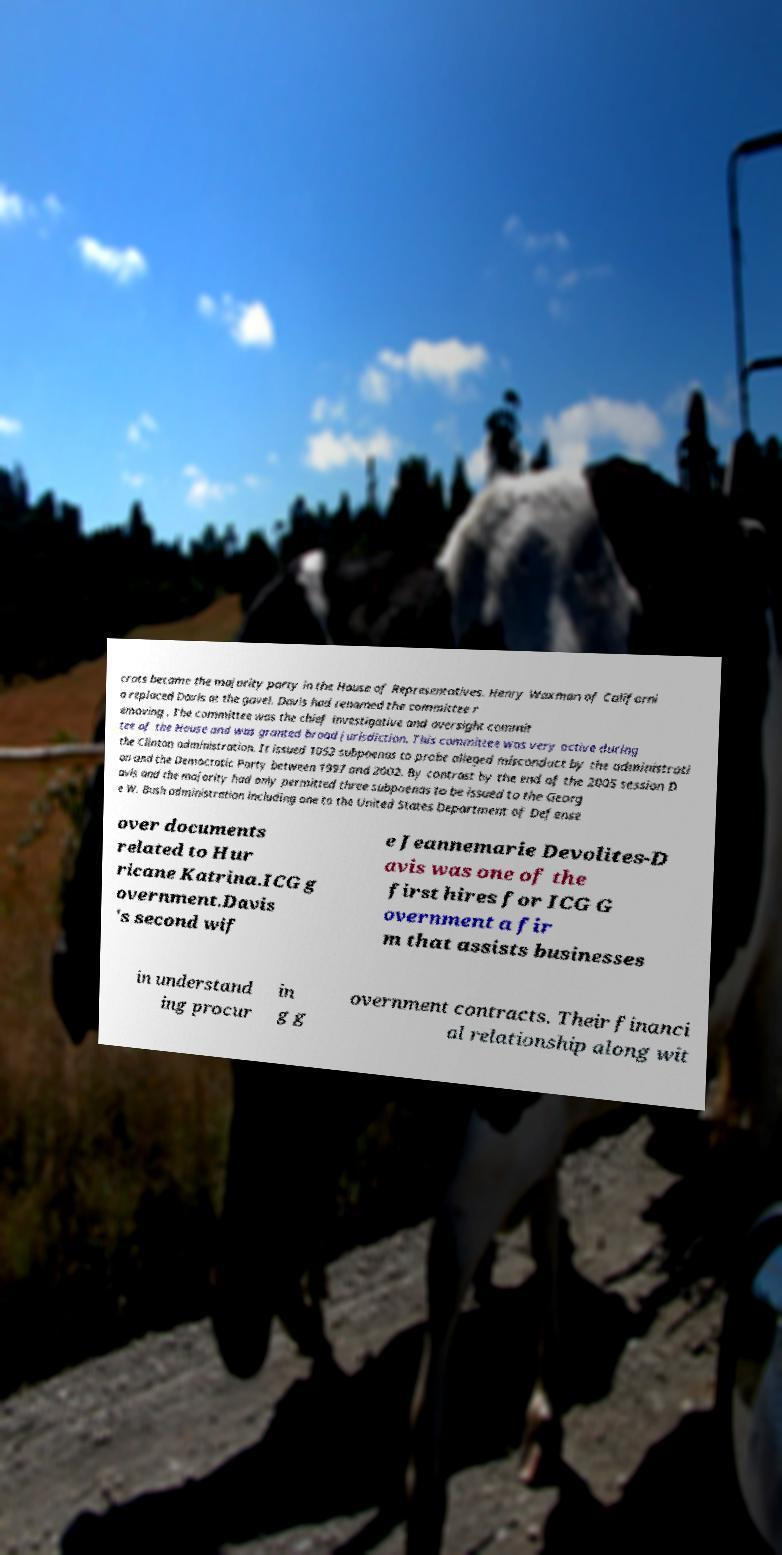Please read and relay the text visible in this image. What does it say? crats became the majority party in the House of Representatives. Henry Waxman of Californi a replaced Davis at the gavel. Davis had renamed the committee r emoving . The committee was the chief investigative and oversight commit tee of the House and was granted broad jurisdiction. This committee was very active during the Clinton administration. It issued 1052 subpoenas to probe alleged misconduct by the administrati on and the Democratic Party between 1997 and 2002. By contrast by the end of the 2005 session D avis and the majority had only permitted three subpoenas to be issued to the Georg e W. Bush administration including one to the United States Department of Defense over documents related to Hur ricane Katrina.ICG g overnment.Davis 's second wif e Jeannemarie Devolites-D avis was one of the first hires for ICG G overnment a fir m that assists businesses in understand ing procur in g g overnment contracts. Their financi al relationship along wit 